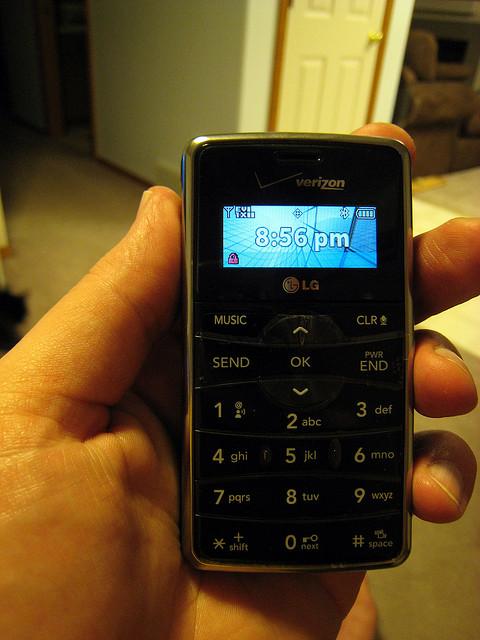What color is the phone on the right?
Short answer required. Black. What is on the screen of the phone?
Write a very short answer. Time. What cell network is this phone on?
Short answer required. Verizon. What time is it?
Give a very brief answer. 8:56 pm. How many buttons are on this remote?
Quick response, please. 19. How many inches long is the cell phone?
Write a very short answer. 3. What is the cell phone carrier?
Give a very brief answer. Verizon. Is it morning or evening?
Concise answer only. Evening. What is on the man's wrist?
Give a very brief answer. Watch. Does the floor have carpet?
Answer briefly. Yes. Where is the knob?
Be succinct. Door. 